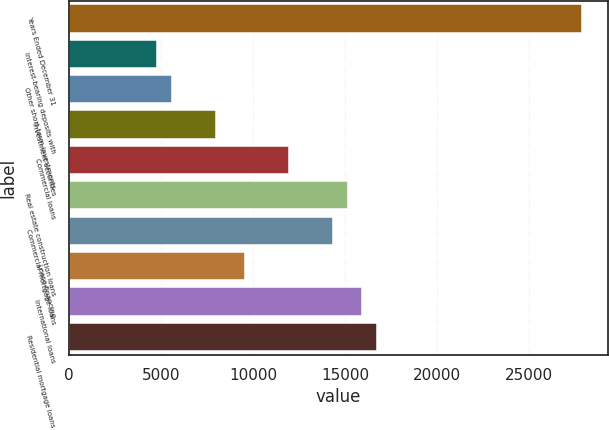Convert chart to OTSL. <chart><loc_0><loc_0><loc_500><loc_500><bar_chart><fcel>Years Ended December 31<fcel>Interest-bearing deposits with<fcel>Other short-term investments<fcel>Investment securities<fcel>Commercial loans<fcel>Real estate construction loans<fcel>Commercial mortgage loans<fcel>Lease financing<fcel>International loans<fcel>Residential mortgage loans<nl><fcel>27859.8<fcel>4776.08<fcel>5572.07<fcel>7960.04<fcel>11940<fcel>15124<fcel>14328<fcel>9552.02<fcel>15919.9<fcel>16715.9<nl></chart> 